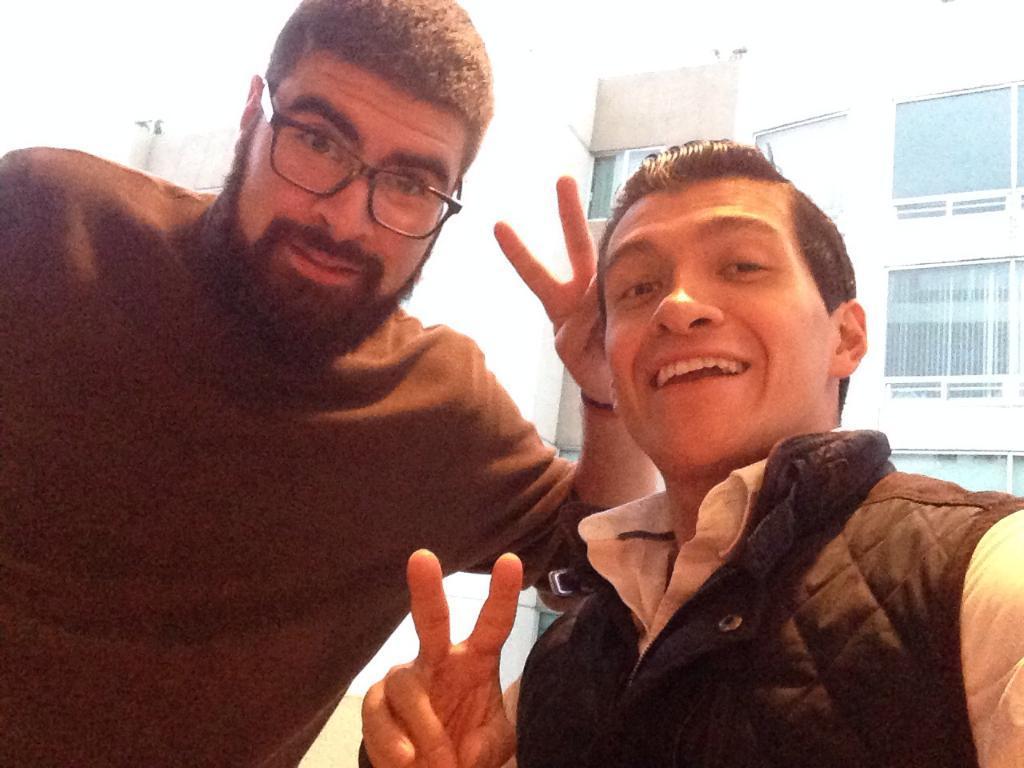Please provide a concise description of this image. In this picture we can see two men. Behind these men, we can see a building. We can see a few windows on this building. 